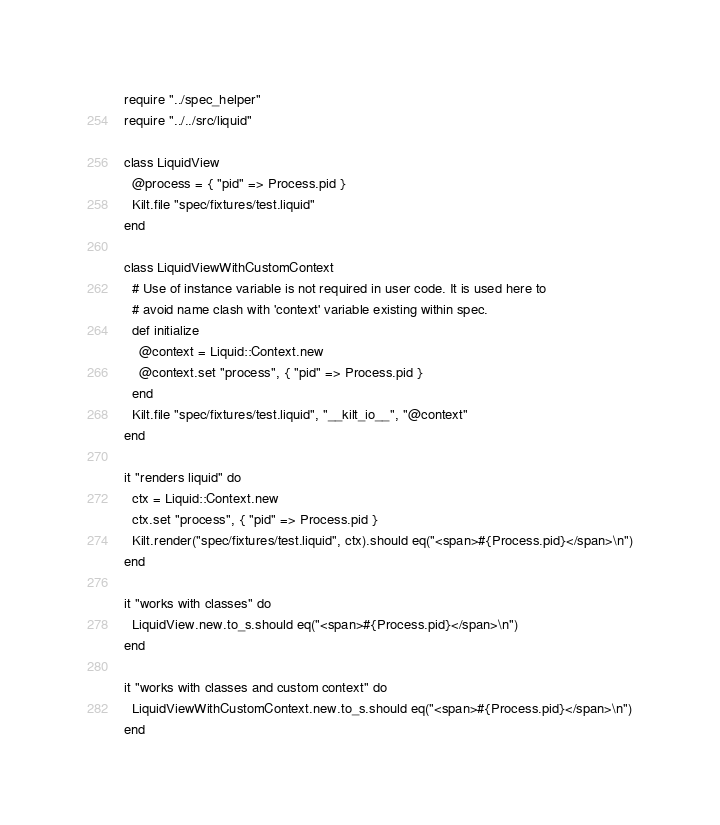Convert code to text. <code><loc_0><loc_0><loc_500><loc_500><_Crystal_>require "../spec_helper"
require "../../src/liquid"

class LiquidView
  @process = { "pid" => Process.pid }
  Kilt.file "spec/fixtures/test.liquid"
end

class LiquidViewWithCustomContext
  # Use of instance variable is not required in user code. It is used here to
  # avoid name clash with 'context' variable existing within spec.
  def initialize
    @context = Liquid::Context.new
    @context.set "process", { "pid" => Process.pid }
  end
  Kilt.file "spec/fixtures/test.liquid", "__kilt_io__", "@context"
end

it "renders liquid" do
  ctx = Liquid::Context.new
  ctx.set "process", { "pid" => Process.pid }
  Kilt.render("spec/fixtures/test.liquid", ctx).should eq("<span>#{Process.pid}</span>\n")
end

it "works with classes" do
  LiquidView.new.to_s.should eq("<span>#{Process.pid}</span>\n")
end

it "works with classes and custom context" do
  LiquidViewWithCustomContext.new.to_s.should eq("<span>#{Process.pid}</span>\n")
end
</code> 